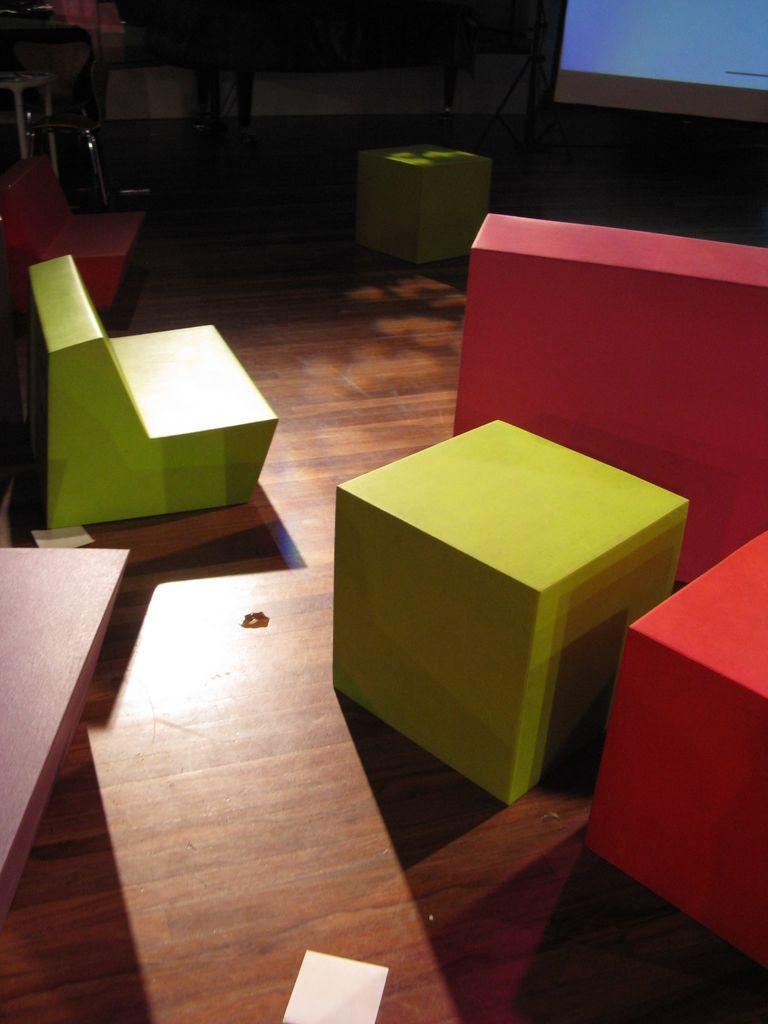How would you summarize this image in a sentence or two? Here we can see wooden blocks, objects and a screen on the floor and the objects are not clear enough to describe. 